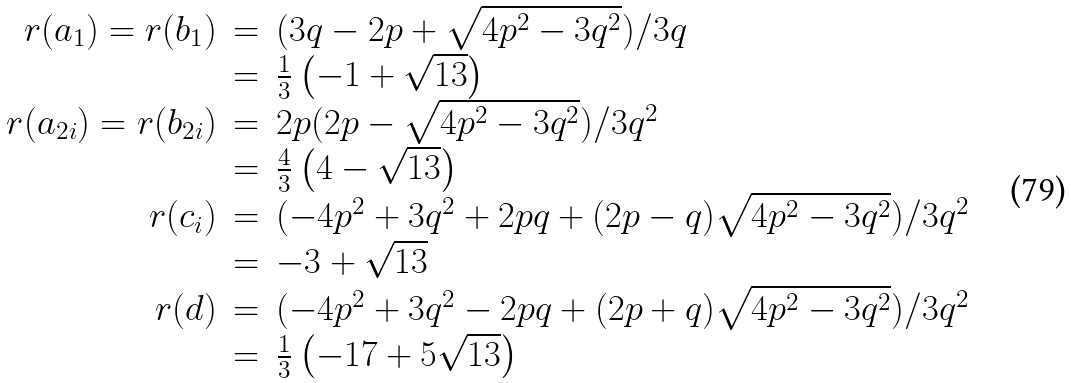Convert formula to latex. <formula><loc_0><loc_0><loc_500><loc_500>\begin{array} { r c l } r ( a _ { 1 } ) = r ( b _ { 1 } ) & = & ( 3 q - 2 p + \sqrt { 4 p ^ { 2 } - 3 q ^ { 2 } } ) / 3 q \\ & = & \frac { 1 } { 3 } \left ( - 1 + \sqrt { 1 3 } \right ) \\ r ( a _ { 2 i } ) = r ( b _ { 2 i } ) & = & 2 p ( 2 p - \sqrt { 4 p ^ { 2 } - 3 q ^ { 2 } } ) / 3 q ^ { 2 } \\ & = & \frac { 4 } { 3 } \left ( 4 - \sqrt { 1 3 } \right ) \\ r ( c _ { i } ) & = & ( - 4 p ^ { 2 } + 3 q ^ { 2 } + 2 p q + ( 2 p - q ) \sqrt { 4 p ^ { 2 } - 3 q ^ { 2 } } ) / 3 q ^ { 2 } \\ & = & - 3 + \sqrt { 1 3 } \\ r ( d ) & = & ( - 4 p ^ { 2 } + 3 q ^ { 2 } - 2 p q + ( 2 p + q ) \sqrt { 4 p ^ { 2 } - 3 q ^ { 2 } } ) / 3 q ^ { 2 } \\ & = & \frac { 1 } { 3 } \left ( - 1 7 + 5 \sqrt { 1 3 } \right ) \end{array}</formula> 